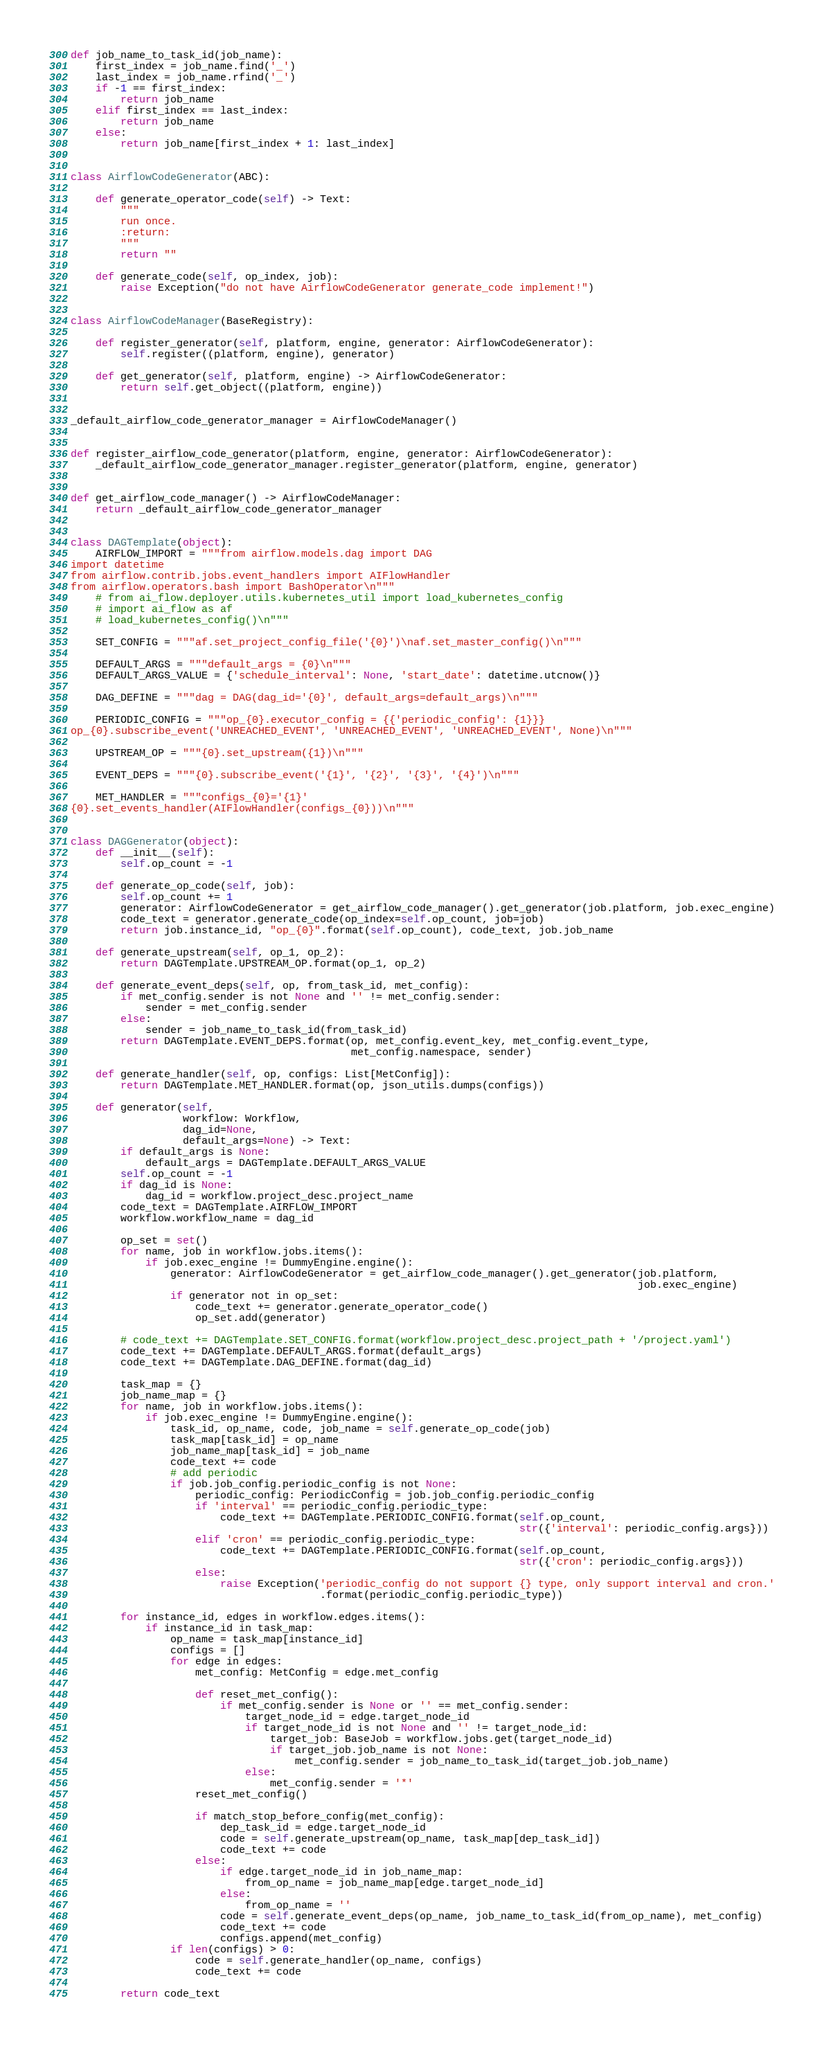<code> <loc_0><loc_0><loc_500><loc_500><_Python_>
def job_name_to_task_id(job_name):
    first_index = job_name.find('_')
    last_index = job_name.rfind('_')
    if -1 == first_index:
        return job_name
    elif first_index == last_index:
        return job_name
    else:
        return job_name[first_index + 1: last_index]


class AirflowCodeGenerator(ABC):

    def generate_operator_code(self) -> Text:
        """
        run once.
        :return:
        """
        return ""

    def generate_code(self, op_index, job):
        raise Exception("do not have AirflowCodeGenerator generate_code implement!")


class AirflowCodeManager(BaseRegistry):

    def register_generator(self, platform, engine, generator: AirflowCodeGenerator):
        self.register((platform, engine), generator)

    def get_generator(self, platform, engine) -> AirflowCodeGenerator:
        return self.get_object((platform, engine))


_default_airflow_code_generator_manager = AirflowCodeManager()


def register_airflow_code_generator(platform, engine, generator: AirflowCodeGenerator):
    _default_airflow_code_generator_manager.register_generator(platform, engine, generator)


def get_airflow_code_manager() -> AirflowCodeManager:
    return _default_airflow_code_generator_manager


class DAGTemplate(object):
    AIRFLOW_IMPORT = """from airflow.models.dag import DAG
import datetime
from airflow.contrib.jobs.event_handlers import AIFlowHandler
from airflow.operators.bash import BashOperator\n"""
    # from ai_flow.deployer.utils.kubernetes_util import load_kubernetes_config
    # import ai_flow as af
    # load_kubernetes_config()\n"""

    SET_CONFIG = """af.set_project_config_file('{0}')\naf.set_master_config()\n"""

    DEFAULT_ARGS = """default_args = {0}\n"""
    DEFAULT_ARGS_VALUE = {'schedule_interval': None, 'start_date': datetime.utcnow()}

    DAG_DEFINE = """dag = DAG(dag_id='{0}', default_args=default_args)\n"""

    PERIODIC_CONFIG = """op_{0}.executor_config = {{'periodic_config': {1}}}
op_{0}.subscribe_event('UNREACHED_EVENT', 'UNREACHED_EVENT', 'UNREACHED_EVENT', None)\n"""

    UPSTREAM_OP = """{0}.set_upstream({1})\n"""

    EVENT_DEPS = """{0}.subscribe_event('{1}', '{2}', '{3}', '{4}')\n"""

    MET_HANDLER = """configs_{0}='{1}'
{0}.set_events_handler(AIFlowHandler(configs_{0}))\n"""


class DAGGenerator(object):
    def __init__(self):
        self.op_count = -1

    def generate_op_code(self, job):
        self.op_count += 1
        generator: AirflowCodeGenerator = get_airflow_code_manager().get_generator(job.platform, job.exec_engine)
        code_text = generator.generate_code(op_index=self.op_count, job=job)
        return job.instance_id, "op_{0}".format(self.op_count), code_text, job.job_name

    def generate_upstream(self, op_1, op_2):
        return DAGTemplate.UPSTREAM_OP.format(op_1, op_2)

    def generate_event_deps(self, op, from_task_id, met_config):
        if met_config.sender is not None and '' != met_config.sender:
            sender = met_config.sender
        else:
            sender = job_name_to_task_id(from_task_id)
        return DAGTemplate.EVENT_DEPS.format(op, met_config.event_key, met_config.event_type,
                                             met_config.namespace, sender)

    def generate_handler(self, op, configs: List[MetConfig]):
        return DAGTemplate.MET_HANDLER.format(op, json_utils.dumps(configs))

    def generator(self,
                  workflow: Workflow,
                  dag_id=None,
                  default_args=None) -> Text:
        if default_args is None:
            default_args = DAGTemplate.DEFAULT_ARGS_VALUE
        self.op_count = -1
        if dag_id is None:
            dag_id = workflow.project_desc.project_name
        code_text = DAGTemplate.AIRFLOW_IMPORT
        workflow.workflow_name = dag_id

        op_set = set()
        for name, job in workflow.jobs.items():
            if job.exec_engine != DummyEngine.engine():
                generator: AirflowCodeGenerator = get_airflow_code_manager().get_generator(job.platform,
                                                                                           job.exec_engine)
                if generator not in op_set:
                    code_text += generator.generate_operator_code()
                    op_set.add(generator)

        # code_text += DAGTemplate.SET_CONFIG.format(workflow.project_desc.project_path + '/project.yaml')
        code_text += DAGTemplate.DEFAULT_ARGS.format(default_args)
        code_text += DAGTemplate.DAG_DEFINE.format(dag_id)

        task_map = {}
        job_name_map = {}
        for name, job in workflow.jobs.items():
            if job.exec_engine != DummyEngine.engine():
                task_id, op_name, code, job_name = self.generate_op_code(job)
                task_map[task_id] = op_name
                job_name_map[task_id] = job_name
                code_text += code
                # add periodic
                if job.job_config.periodic_config is not None:
                    periodic_config: PeriodicConfig = job.job_config.periodic_config
                    if 'interval' == periodic_config.periodic_type:
                        code_text += DAGTemplate.PERIODIC_CONFIG.format(self.op_count,
                                                                        str({'interval': periodic_config.args}))
                    elif 'cron' == periodic_config.periodic_type:
                        code_text += DAGTemplate.PERIODIC_CONFIG.format(self.op_count,
                                                                        str({'cron': periodic_config.args}))
                    else:
                        raise Exception('periodic_config do not support {} type, only support interval and cron.'
                                        .format(periodic_config.periodic_type))

        for instance_id, edges in workflow.edges.items():
            if instance_id in task_map:
                op_name = task_map[instance_id]
                configs = []
                for edge in edges:
                    met_config: MetConfig = edge.met_config

                    def reset_met_config():
                        if met_config.sender is None or '' == met_config.sender:
                            target_node_id = edge.target_node_id
                            if target_node_id is not None and '' != target_node_id:
                                target_job: BaseJob = workflow.jobs.get(target_node_id)
                                if target_job.job_name is not None:
                                    met_config.sender = job_name_to_task_id(target_job.job_name)
                            else:
                                met_config.sender = '*'
                    reset_met_config()

                    if match_stop_before_config(met_config):
                        dep_task_id = edge.target_node_id
                        code = self.generate_upstream(op_name, task_map[dep_task_id])
                        code_text += code
                    else:
                        if edge.target_node_id in job_name_map:
                            from_op_name = job_name_map[edge.target_node_id]
                        else:
                            from_op_name = ''
                        code = self.generate_event_deps(op_name, job_name_to_task_id(from_op_name), met_config)
                        code_text += code
                        configs.append(met_config)
                if len(configs) > 0:
                    code = self.generate_handler(op_name, configs)
                    code_text += code

        return code_text
</code> 